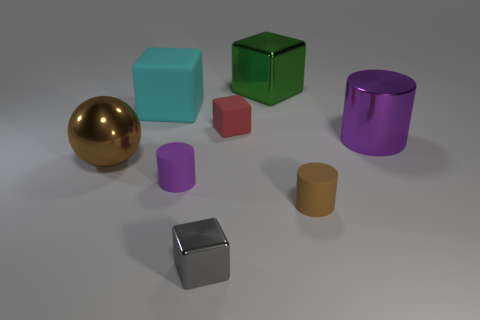Subtract all purple blocks. Subtract all red balls. How many blocks are left? 4 Add 1 red rubber objects. How many objects exist? 9 Subtract all spheres. How many objects are left? 7 Subtract 0 gray spheres. How many objects are left? 8 Subtract all big gray matte cubes. Subtract all brown rubber cylinders. How many objects are left? 7 Add 1 big cyan matte objects. How many big cyan matte objects are left? 2 Add 1 purple rubber cylinders. How many purple rubber cylinders exist? 2 